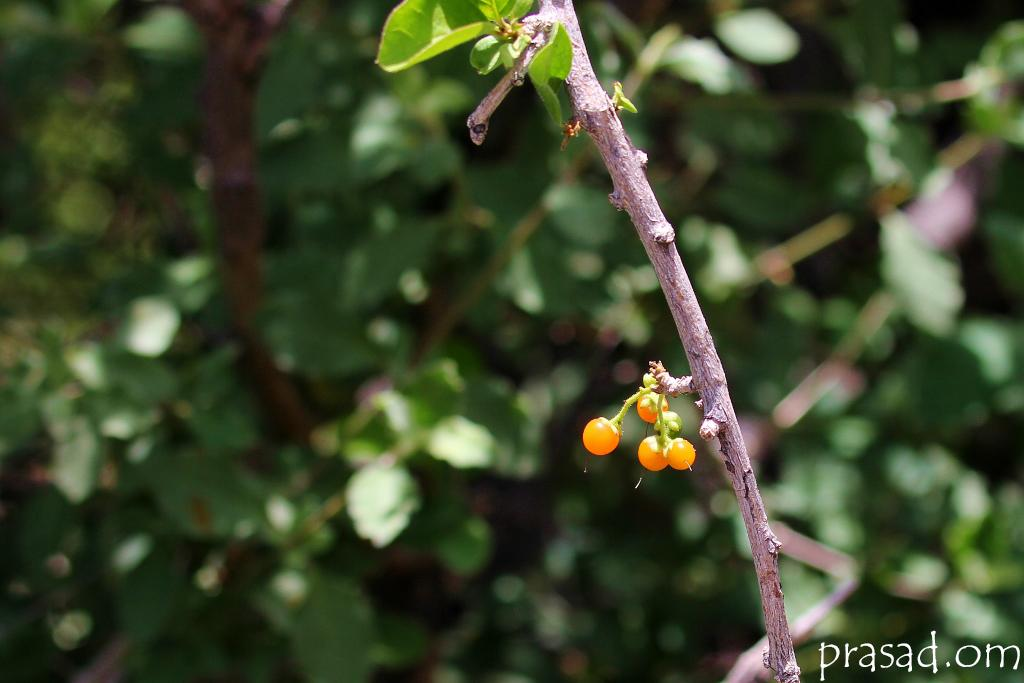Where was the image taken? The image is taken outdoors. What can be seen in the background of the image? There are plants with green leaves in the background. Can you describe the plant on the right side of the image? The plant on the right side of the image has a stem, leaves, and fruits. What type of property can be seen in the image? There is no property visible in the image; it primarily features plants and greenery. What season is it in the image, considering the presence of clouds? The presence of clouds does not necessarily indicate a specific season, as clouds can be present in various seasons. 